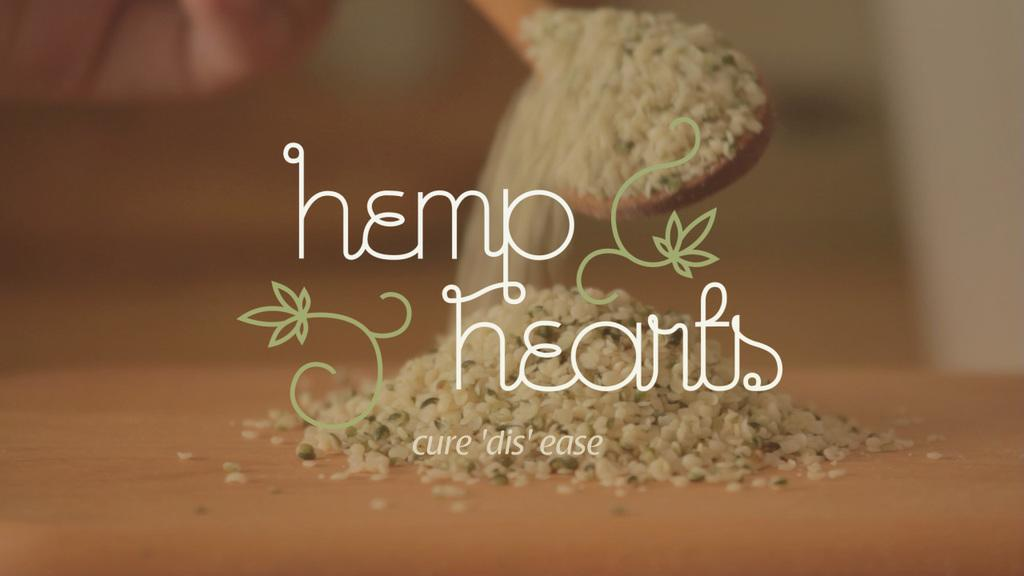What is the main subject of the image? The main subject of the image is a spoon of grains. What is happening to the grains in the image? The grains are falling on a board in the image. Are there any visible marks on the image? Yes, there are watermarks on the image. What type of kitty is guiding the government in the image? There is no kitty or government present in the image; it features a spoon of grains falling on a board with watermarks. 